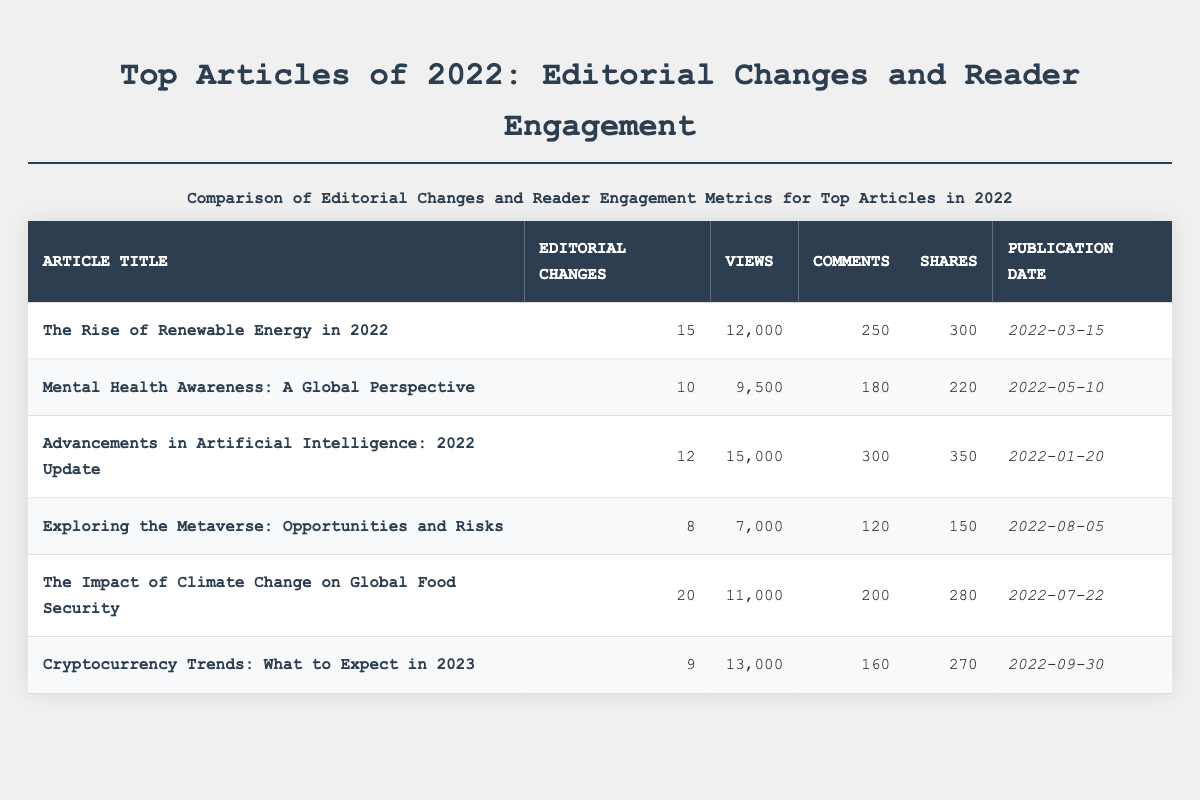What is the title of the article with the highest number of editorial changes? By examining the "Editorial Changes" column, the article with the highest number of changes has the value of 20. Checking which article corresponds to this value in the table, we find that "The Impact of Climate Change on Global Food Security" has 20 editorial changes.
Answer: The Impact of Climate Change on Global Food Security What is the total number of views for all articles combined? To find the total views, sum the "Views" values: 12000 + 9500 + 15000 + 7000 + 11000 + 13000 = 73500.
Answer: 73500 Which article had the least number of comments? Looking at the "Comments" column, the minimum value is 120. The article titled "Exploring the Metaverse: Opportunities and Risks" corresponds to this value, indicating that it had the least number of comments.
Answer: Exploring the Metaverse: Opportunities and Risks Is the article "Cryptocurrency Trends: What to Expect in 2023" among the top three articles with the most views? The views for "Cryptocurrency Trends: What to Expect in 2023" are 13000. Comparing this to the views of other articles, only "Advancements in Artificial Intelligence: 2022 Update" (15000) and "The Rise of Renewable Energy in 2022" (12000) have higher views. Thus, it ranks third with 13000 views. Therefore, yes, it is among the top three articles by views.
Answer: Yes What is the average number of shares across all articles? First, sum the "Shares" values: 300 + 220 + 350 + 150 + 280 + 270 = 1570. There are 6 articles. To find the average, divide the total shares by the number of articles: 1570 / 6 ≈ 261.67.
Answer: 261.67 